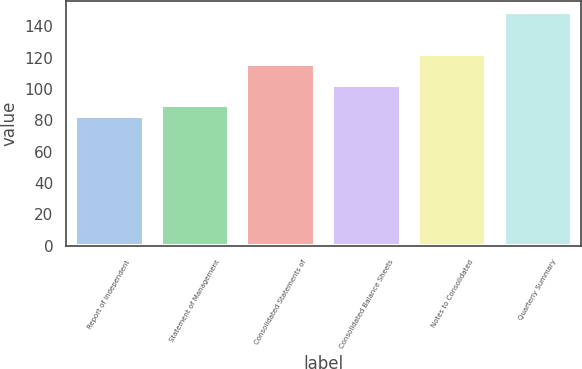Convert chart. <chart><loc_0><loc_0><loc_500><loc_500><bar_chart><fcel>Report of Independent<fcel>Statement of Management<fcel>Consolidated Statements of<fcel>Consolidated Balance Sheets<fcel>Notes to Consolidated<fcel>Quarterly Summary<nl><fcel>83<fcel>89.6<fcel>116<fcel>102.8<fcel>122.6<fcel>149<nl></chart> 